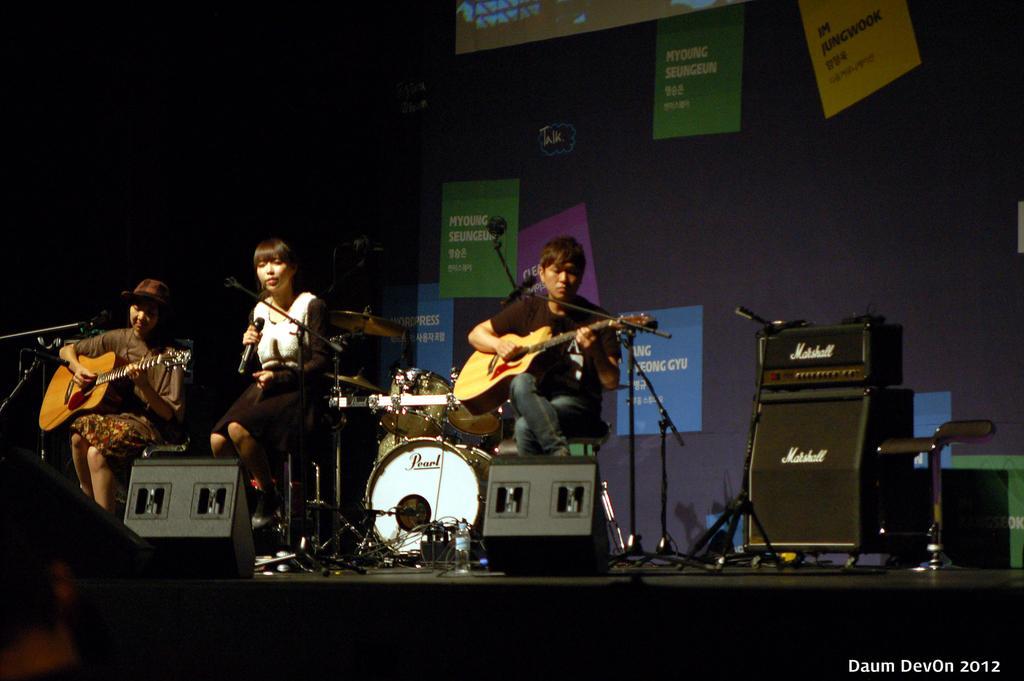Describe this image in one or two sentences. The person wearing black T-shirt is holding a guitar in his hand in front a mike and the person wearing black and white dress is singing in mike and the person wearing brown dress is playing guitar and there is also drums in the background and there is a banner in the background with something written on it. 